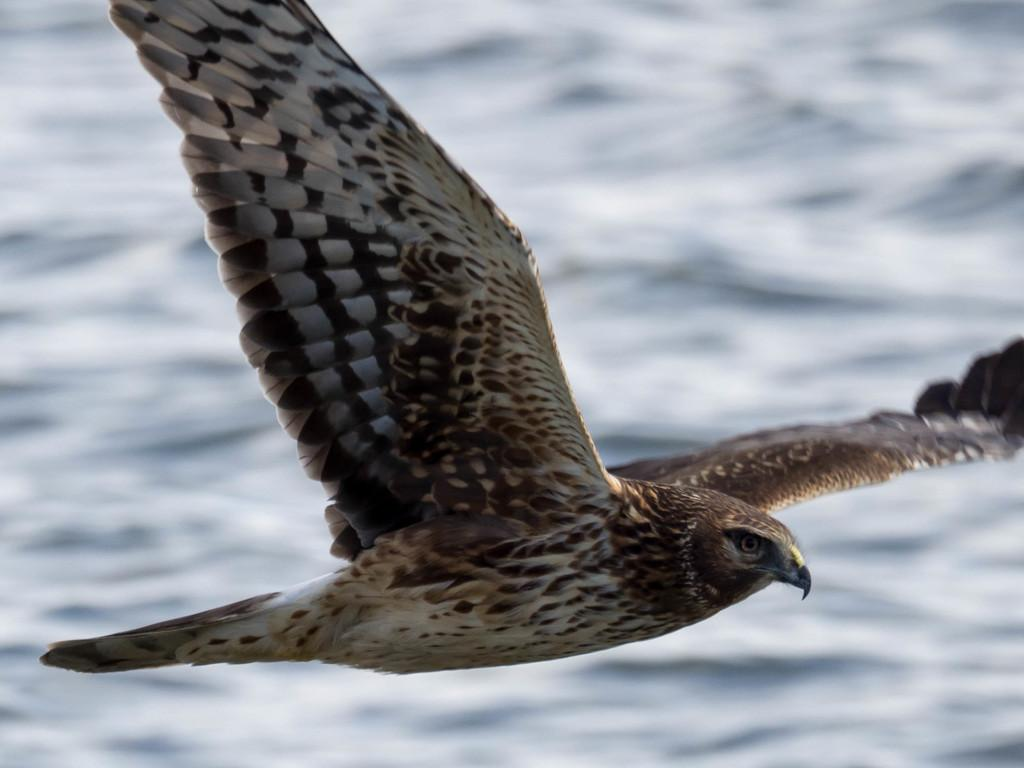What type of animal can be seen in the image? There is a bird in the image. What is the bird doing in the image? The bird is flying in the air. What type of riddle does the bird present to the viewer in the image? There is no riddle presented by the bird in the image; it is simply flying. 